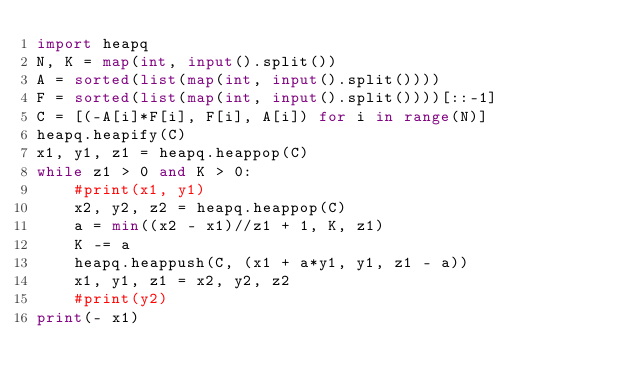Convert code to text. <code><loc_0><loc_0><loc_500><loc_500><_Python_>import heapq
N, K = map(int, input().split())
A = sorted(list(map(int, input().split())))
F = sorted(list(map(int, input().split())))[::-1]
C = [(-A[i]*F[i], F[i], A[i]) for i in range(N)]
heapq.heapify(C)
x1, y1, z1 = heapq.heappop(C)
while z1 > 0 and K > 0:
    #print(x1, y1)
    x2, y2, z2 = heapq.heappop(C)
    a = min((x2 - x1)//z1 + 1, K, z1)
    K -= a
    heapq.heappush(C, (x1 + a*y1, y1, z1 - a))
    x1, y1, z1 = x2, y2, z2
    #print(y2)
print(- x1)</code> 